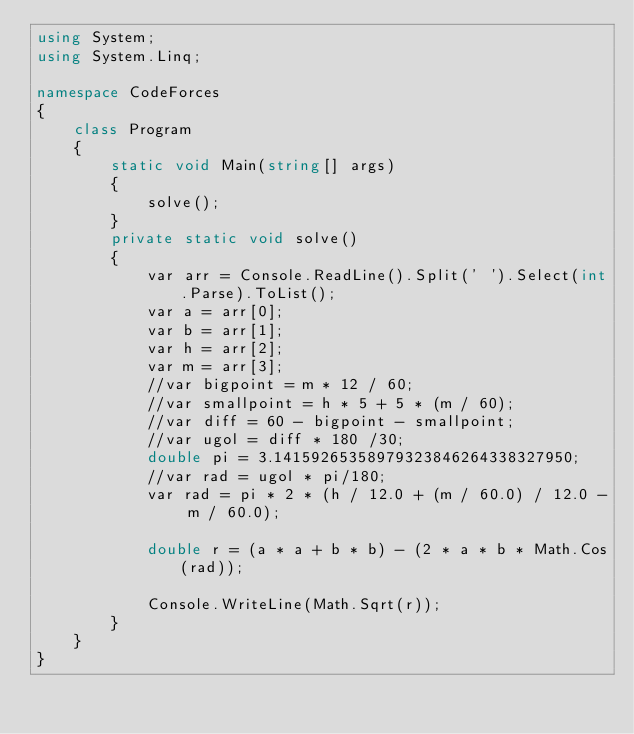<code> <loc_0><loc_0><loc_500><loc_500><_C#_>using System;
using System.Linq;

namespace CodeForces
{
    class Program
    {
        static void Main(string[] args)
        {
            solve();
        }
        private static void solve()
        {
            var arr = Console.ReadLine().Split(' ').Select(int.Parse).ToList();
            var a = arr[0];
            var b = arr[1];
            var h = arr[2];
            var m = arr[3];
            //var bigpoint = m * 12 / 60;
            //var smallpoint = h * 5 + 5 * (m / 60);
            //var diff = 60 - bigpoint - smallpoint;
            //var ugol = diff * 180 /30;
            double pi = 3.14159265358979323846264338327950;
            //var rad = ugol * pi/180;
            var rad = pi * 2 * (h / 12.0 + (m / 60.0) / 12.0 - m / 60.0);

            double r = (a * a + b * b) - (2 * a * b * Math.Cos(rad));

            Console.WriteLine(Math.Sqrt(r));
        }
    }
}</code> 